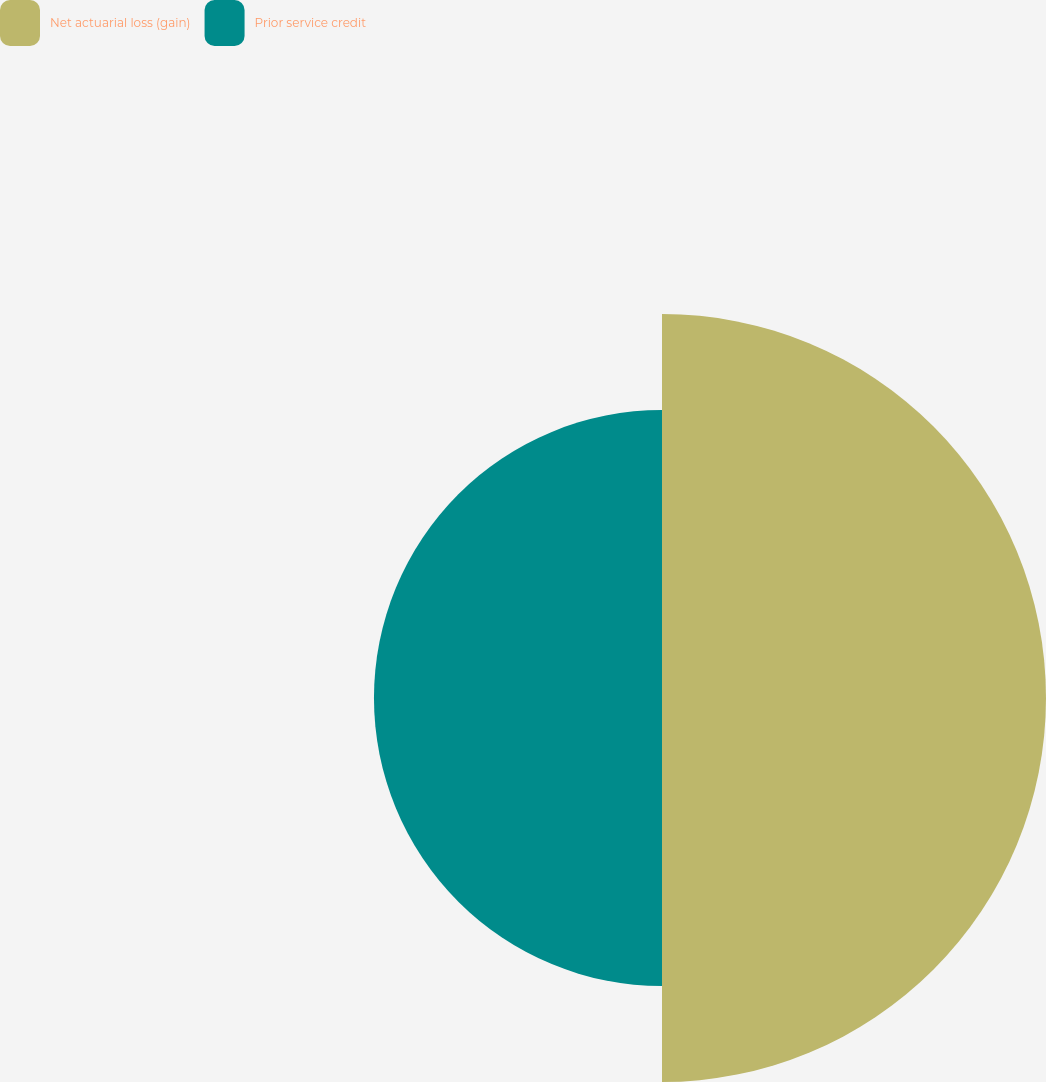Convert chart to OTSL. <chart><loc_0><loc_0><loc_500><loc_500><pie_chart><fcel>Net actuarial loss (gain)<fcel>Prior service credit<nl><fcel>57.14%<fcel>42.86%<nl></chart> 